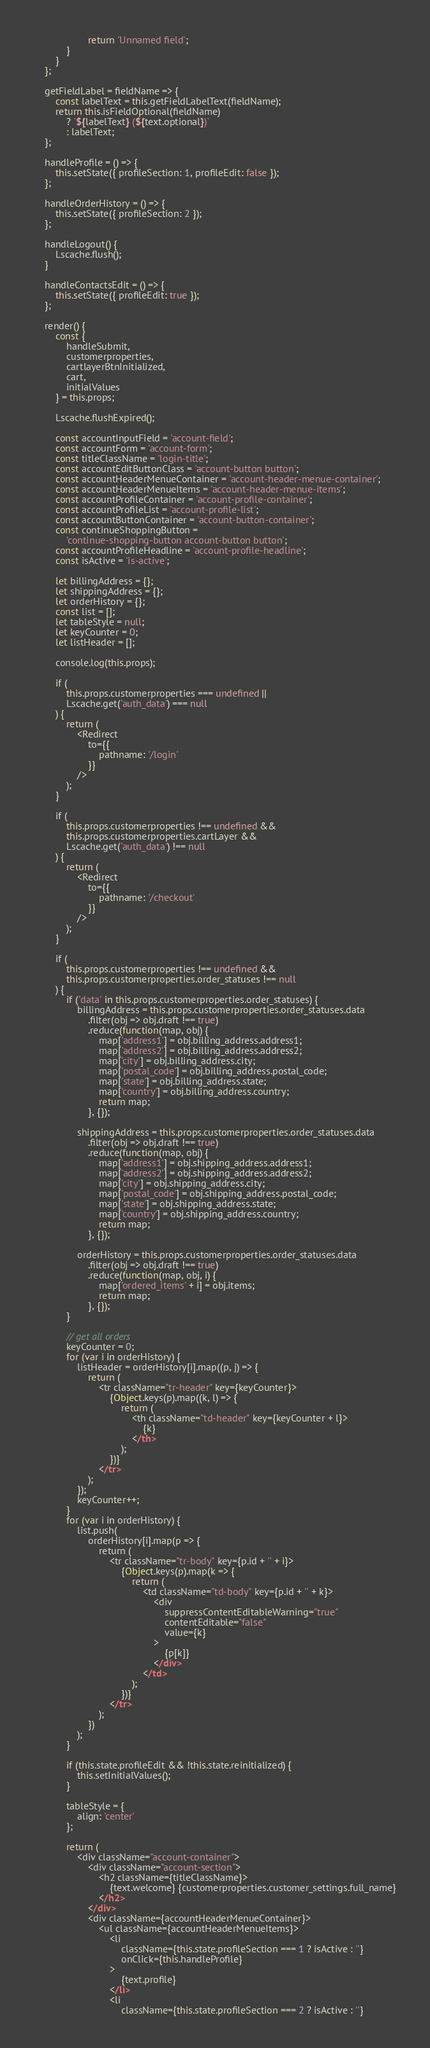Convert code to text. <code><loc_0><loc_0><loc_500><loc_500><_JavaScript_>					return 'Unnamed field';
			}
		}
	};

	getFieldLabel = fieldName => {
		const labelText = this.getFieldLabelText(fieldName);
		return this.isFieldOptional(fieldName)
			? `${labelText} (${text.optional})`
			: labelText;
	};

	handleProfile = () => {
		this.setState({ profileSection: 1, profileEdit: false });
	};

	handleOrderHistory = () => {
		this.setState({ profileSection: 2 });
	};

	handleLogout() {
		Lscache.flush();
	}

	handleContactsEdit = () => {
		this.setState({ profileEdit: true });
	};

	render() {
		const {
			handleSubmit,
			customerproperties,
			cartlayerBtnInitialized,
			cart,
			initialValues
		} = this.props;

		Lscache.flushExpired();

		const accountInputField = 'account-field';
		const accountForm = 'account-form';
		const titleClassName = 'login-title';
		const accountEditButtonClass = 'account-button button';
		const accountHeaderMenueContainer = 'account-header-menue-container';
		const accountHeaderMenueItems = 'account-header-menue-items';
		const accountProfileContainer = 'account-profile-container';
		const accountProfileList = 'account-profile-list';
		const accountButtonContainer = 'account-button-container';
		const continueShoppingButton =
			'continue-shopping-button account-button button';
		const accountProfileHeadline = 'account-profile-headline';
		const isActive = 'is-active';

		let billingAddress = {};
		let shippingAddress = {};
		let orderHistory = {};
		const list = [];
		let tableStyle = null;
		let keyCounter = 0;
		let listHeader = [];

		console.log(this.props);

		if (
			this.props.customerproperties === undefined ||
			Lscache.get('auth_data') === null
		) {
			return (
				<Redirect
					to={{
						pathname: '/login'
					}}
				/>
			);
		}

		if (
			this.props.customerproperties !== undefined &&
			this.props.customerproperties.cartLayer &&
			Lscache.get('auth_data') !== null
		) {
			return (
				<Redirect
					to={{
						pathname: '/checkout'
					}}
				/>
			);
		}

		if (
			this.props.customerproperties !== undefined &&
			this.props.customerproperties.order_statuses !== null
		) {
			if ('data' in this.props.customerproperties.order_statuses) {
				billingAddress = this.props.customerproperties.order_statuses.data
					.filter(obj => obj.draft !== true)
					.reduce(function(map, obj) {
						map['address1'] = obj.billing_address.address1;
						map['address2'] = obj.billing_address.address2;
						map['city'] = obj.billing_address.city;
						map['postal_code'] = obj.billing_address.postal_code;
						map['state'] = obj.billing_address.state;
						map['country'] = obj.billing_address.country;
						return map;
					}, {});

				shippingAddress = this.props.customerproperties.order_statuses.data
					.filter(obj => obj.draft !== true)
					.reduce(function(map, obj) {
						map['address1'] = obj.shipping_address.address1;
						map['address2'] = obj.shipping_address.address2;
						map['city'] = obj.shipping_address.city;
						map['postal_code'] = obj.shipping_address.postal_code;
						map['state'] = obj.shipping_address.state;
						map['country'] = obj.shipping_address.country;
						return map;
					}, {});

				orderHistory = this.props.customerproperties.order_statuses.data
					.filter(obj => obj.draft !== true)
					.reduce(function(map, obj, i) {
						map['ordered_items' + i] = obj.items;
						return map;
					}, {});
			}

			// get all orders
			keyCounter = 0;
			for (var i in orderHistory) {
				listHeader = orderHistory[i].map((p, j) => {
					return (
						<tr className="tr-header" key={keyCounter}>
							{Object.keys(p).map((k, l) => {
								return (
									<th className="td-header" key={keyCounter + l}>
										{k}
									</th>
								);
							})}
						</tr>
					);
				});
				keyCounter++;
			}
			for (var i in orderHistory) {
				list.push(
					orderHistory[i].map(p => {
						return (
							<tr className="tr-body" key={p.id + '' + i}>
								{Object.keys(p).map(k => {
									return (
										<td className="td-body" key={p.id + '' + k}>
											<div
												suppressContentEditableWarning="true"
												contentEditable="false"
												value={k}
											>
												{p[k]}
											</div>
										</td>
									);
								})}
							</tr>
						);
					})
				);
			}

			if (this.state.profileEdit && !this.state.reinitialized) {
				this.setInitialValues();
			}

			tableStyle = {
				align: 'center'
			};

			return (
				<div className="account-container">
					<div className="account-section">
						<h2 className={titleClassName}>
							{text.welcome} {customerproperties.customer_settings.full_name}
						</h2>
					</div>
					<div className={accountHeaderMenueContainer}>
						<ul className={accountHeaderMenueItems}>
							<li
								className={this.state.profileSection === 1 ? isActive : ''}
								onClick={this.handleProfile}
							>
								{text.profile}
							</li>
							<li
								className={this.state.profileSection === 2 ? isActive : ''}</code> 